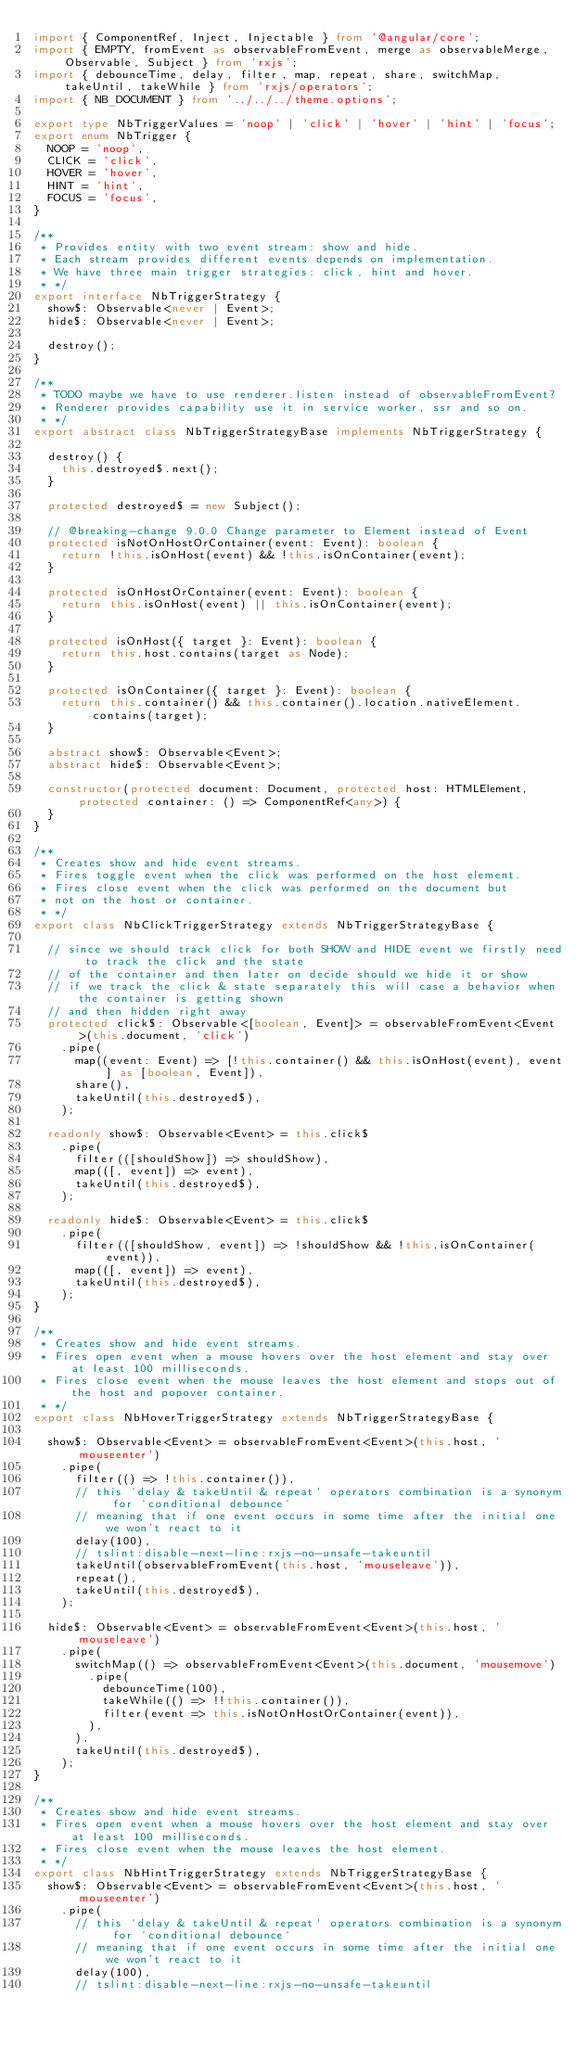Convert code to text. <code><loc_0><loc_0><loc_500><loc_500><_TypeScript_>import { ComponentRef, Inject, Injectable } from '@angular/core';
import { EMPTY, fromEvent as observableFromEvent, merge as observableMerge, Observable, Subject } from 'rxjs';
import { debounceTime, delay, filter, map, repeat, share, switchMap, takeUntil, takeWhile } from 'rxjs/operators';
import { NB_DOCUMENT } from '../../../theme.options';

export type NbTriggerValues = 'noop' | 'click' | 'hover' | 'hint' | 'focus';
export enum NbTrigger {
  NOOP = 'noop',
  CLICK = 'click',
  HOVER = 'hover',
  HINT = 'hint',
  FOCUS = 'focus',
}

/**
 * Provides entity with two event stream: show and hide.
 * Each stream provides different events depends on implementation.
 * We have three main trigger strategies: click, hint and hover.
 * */
export interface NbTriggerStrategy {
  show$: Observable<never | Event>;
  hide$: Observable<never | Event>;

  destroy();
}

/**
 * TODO maybe we have to use renderer.listen instead of observableFromEvent?
 * Renderer provides capability use it in service worker, ssr and so on.
 * */
export abstract class NbTriggerStrategyBase implements NbTriggerStrategy {

  destroy() {
    this.destroyed$.next();
  }

  protected destroyed$ = new Subject();

  // @breaking-change 9.0.0 Change parameter to Element instead of Event
  protected isNotOnHostOrContainer(event: Event): boolean {
    return !this.isOnHost(event) && !this.isOnContainer(event);
  }

  protected isOnHostOrContainer(event: Event): boolean {
    return this.isOnHost(event) || this.isOnContainer(event);
  }

  protected isOnHost({ target }: Event): boolean {
    return this.host.contains(target as Node);
  }

  protected isOnContainer({ target }: Event): boolean {
    return this.container() && this.container().location.nativeElement.contains(target);
  }

  abstract show$: Observable<Event>;
  abstract hide$: Observable<Event>;

  constructor(protected document: Document, protected host: HTMLElement, protected container: () => ComponentRef<any>) {
  }
}

/**
 * Creates show and hide event streams.
 * Fires toggle event when the click was performed on the host element.
 * Fires close event when the click was performed on the document but
 * not on the host or container.
 * */
export class NbClickTriggerStrategy extends NbTriggerStrategyBase {

  // since we should track click for both SHOW and HIDE event we firstly need to track the click and the state
  // of the container and then later on decide should we hide it or show
  // if we track the click & state separately this will case a behavior when the container is getting shown
  // and then hidden right away
  protected click$: Observable<[boolean, Event]> = observableFromEvent<Event>(this.document, 'click')
    .pipe(
      map((event: Event) => [!this.container() && this.isOnHost(event), event] as [boolean, Event]),
      share(),
      takeUntil(this.destroyed$),
    );

  readonly show$: Observable<Event> = this.click$
    .pipe(
      filter(([shouldShow]) => shouldShow),
      map(([, event]) => event),
      takeUntil(this.destroyed$),
    );

  readonly hide$: Observable<Event> = this.click$
    .pipe(
      filter(([shouldShow, event]) => !shouldShow && !this.isOnContainer(event)),
      map(([, event]) => event),
      takeUntil(this.destroyed$),
    );
}

/**
 * Creates show and hide event streams.
 * Fires open event when a mouse hovers over the host element and stay over at least 100 milliseconds.
 * Fires close event when the mouse leaves the host element and stops out of the host and popover container.
 * */
export class NbHoverTriggerStrategy extends NbTriggerStrategyBase {

  show$: Observable<Event> = observableFromEvent<Event>(this.host, 'mouseenter')
    .pipe(
      filter(() => !this.container()),
      // this `delay & takeUntil & repeat` operators combination is a synonym for `conditional debounce`
      // meaning that if one event occurs in some time after the initial one we won't react to it
      delay(100),
      // tslint:disable-next-line:rxjs-no-unsafe-takeuntil
      takeUntil(observableFromEvent(this.host, 'mouseleave')),
      repeat(),
      takeUntil(this.destroyed$),
    );

  hide$: Observable<Event> = observableFromEvent<Event>(this.host, 'mouseleave')
    .pipe(
      switchMap(() => observableFromEvent<Event>(this.document, 'mousemove')
        .pipe(
          debounceTime(100),
          takeWhile(() => !!this.container()),
          filter(event => this.isNotOnHostOrContainer(event)),
        ),
      ),
      takeUntil(this.destroyed$),
    );
}

/**
 * Creates show and hide event streams.
 * Fires open event when a mouse hovers over the host element and stay over at least 100 milliseconds.
 * Fires close event when the mouse leaves the host element.
 * */
export class NbHintTriggerStrategy extends NbTriggerStrategyBase {
  show$: Observable<Event> = observableFromEvent<Event>(this.host, 'mouseenter')
    .pipe(
      // this `delay & takeUntil & repeat` operators combination is a synonym for `conditional debounce`
      // meaning that if one event occurs in some time after the initial one we won't react to it
      delay(100),
      // tslint:disable-next-line:rxjs-no-unsafe-takeuntil</code> 